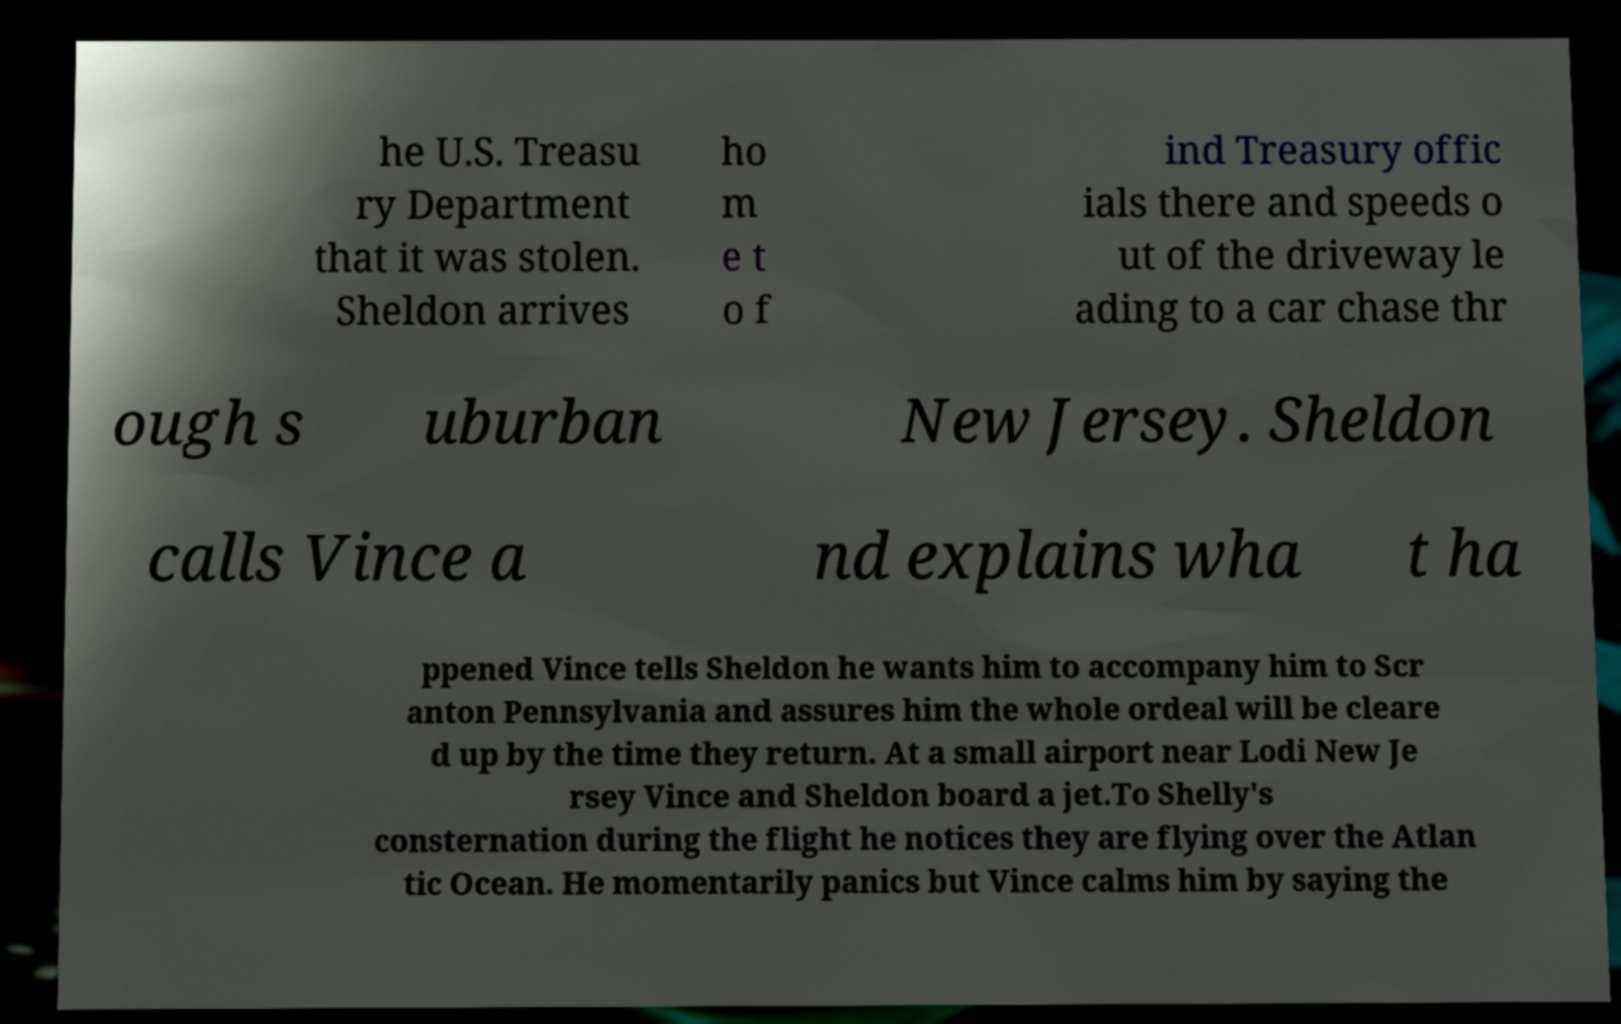For documentation purposes, I need the text within this image transcribed. Could you provide that? he U.S. Treasu ry Department that it was stolen. Sheldon arrives ho m e t o f ind Treasury offic ials there and speeds o ut of the driveway le ading to a car chase thr ough s uburban New Jersey. Sheldon calls Vince a nd explains wha t ha ppened Vince tells Sheldon he wants him to accompany him to Scr anton Pennsylvania and assures him the whole ordeal will be cleare d up by the time they return. At a small airport near Lodi New Je rsey Vince and Sheldon board a jet.To Shelly's consternation during the flight he notices they are flying over the Atlan tic Ocean. He momentarily panics but Vince calms him by saying the 